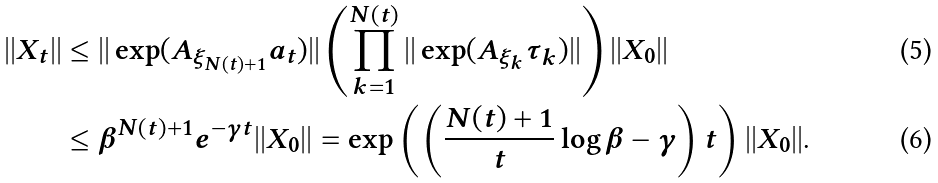<formula> <loc_0><loc_0><loc_500><loc_500>| | X _ { t } | | & \leq | | \exp ( A _ { \xi _ { N ( t ) + 1 } } a _ { t } ) | | \left ( \prod _ { k = 1 } ^ { N ( t ) } | | \exp ( A _ { \xi _ { k } } \tau _ { k } ) | | \right ) | | X _ { 0 } | | \\ & \leq \beta ^ { N ( t ) + 1 } e ^ { - \gamma t } | | X _ { 0 } | | = \exp \left ( \left ( \frac { N ( t ) + 1 } { t } \log \beta - \gamma \right ) t \right ) | | X _ { 0 } | | .</formula> 